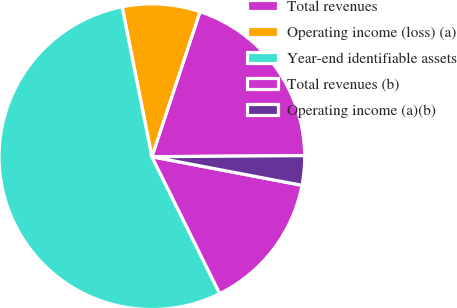<chart> <loc_0><loc_0><loc_500><loc_500><pie_chart><fcel>Total revenues<fcel>Operating income (loss) (a)<fcel>Year-end identifiable assets<fcel>Total revenues (b)<fcel>Operating income (a)(b)<nl><fcel>19.79%<fcel>8.22%<fcel>54.21%<fcel>14.68%<fcel>3.11%<nl></chart> 